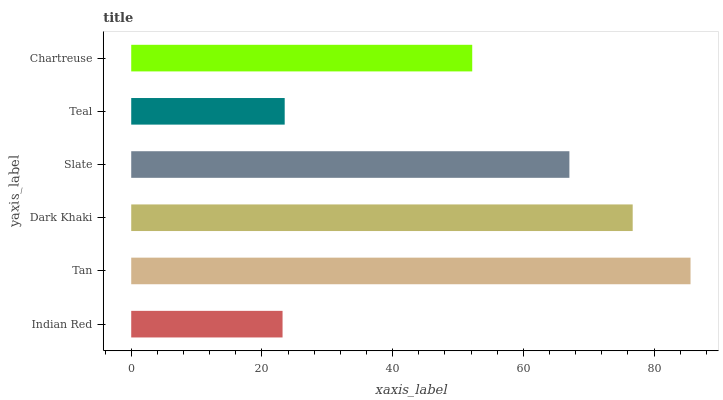Is Indian Red the minimum?
Answer yes or no. Yes. Is Tan the maximum?
Answer yes or no. Yes. Is Dark Khaki the minimum?
Answer yes or no. No. Is Dark Khaki the maximum?
Answer yes or no. No. Is Tan greater than Dark Khaki?
Answer yes or no. Yes. Is Dark Khaki less than Tan?
Answer yes or no. Yes. Is Dark Khaki greater than Tan?
Answer yes or no. No. Is Tan less than Dark Khaki?
Answer yes or no. No. Is Slate the high median?
Answer yes or no. Yes. Is Chartreuse the low median?
Answer yes or no. Yes. Is Teal the high median?
Answer yes or no. No. Is Slate the low median?
Answer yes or no. No. 